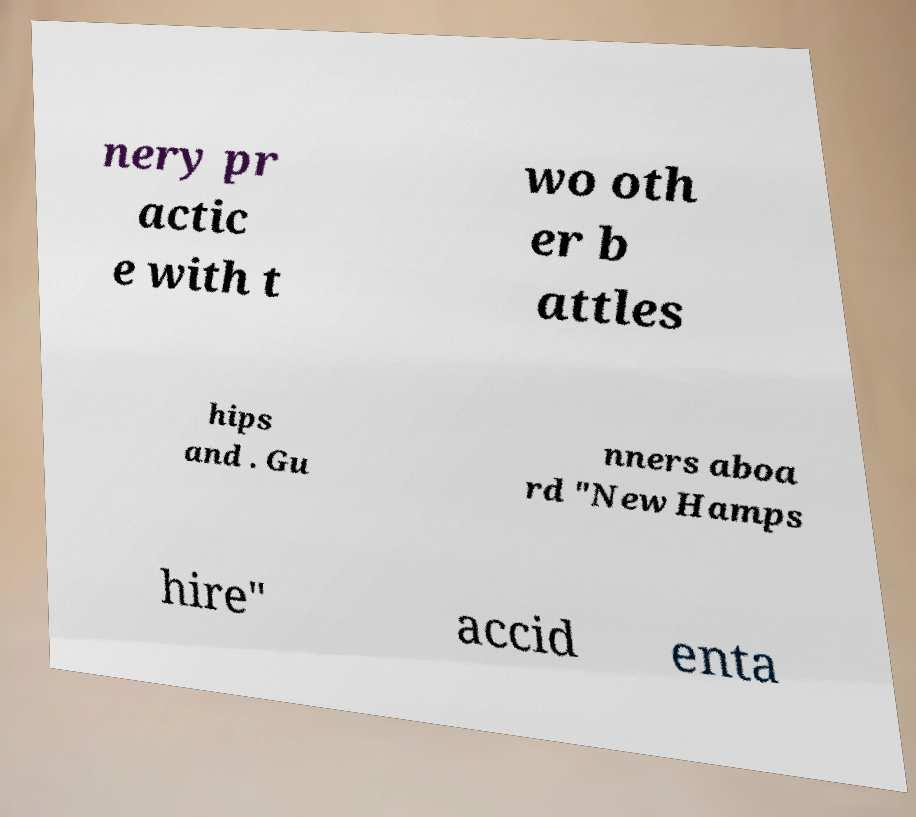Can you accurately transcribe the text from the provided image for me? nery pr actic e with t wo oth er b attles hips and . Gu nners aboa rd "New Hamps hire" accid enta 